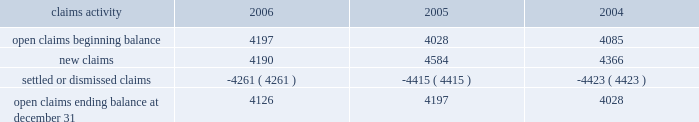Potentially responsible parties , and existing technology , laws , and regulations .
The ultimate liability for remediation is difficult to determine because of the number of potentially responsible parties involved , site- specific cost sharing arrangements with other potentially responsible parties , the degree of contamination by various wastes , the scarcity and quality of volumetric data related to many of the sites , and the speculative nature of remediation costs .
Current obligations are not expected to have a material adverse effect on our consolidated results of operations , financial condition , or liquidity .
Personal injury 2013 the cost of personal injuries to employees and others related to our activities is charged to expense based on estimates of the ultimate cost and number of incidents each year .
We use third-party actuaries to assist us with measuring the expense and liability , including unasserted claims .
The federal employers 2019 liability act ( fela ) governs compensation for work-related accidents .
Under fela , damages are assessed based on a finding of fault through litigation or out-of-court settlements .
We offer a comprehensive variety of services and rehabilitation programs for employees who are injured at work .
Annual expenses for personal injury-related events were $ 240 million in 2006 , $ 247 million in 2005 , and $ 288 million in 2004 .
As of december 31 , 2006 and 2005 , we had accrued liabilities of $ 631 million and $ 619 million for future personal injury costs , respectively , of which $ 233 million and $ 274 million was recorded in current liabilities as accrued casualty costs , respectively .
Our personal injury liability is discounted to present value using applicable u.s .
Treasury rates .
Approximately 87% ( 87 % ) of the recorded liability related to asserted claims , and approximately 13% ( 13 % ) related to unasserted claims .
Estimates can vary over time due to evolving trends in litigation .
Our personal injury claims activity was as follows : claims activity 2006 2005 2004 .
Depreciation 2013 the railroad industry is capital intensive .
Properties are carried at cost .
Provisions for depreciation are computed principally on the straight-line method based on estimated service lives of depreciable property .
The lives are calculated using a separate composite annual percentage rate for each depreciable property group , based on the results of internal depreciation studies .
We are required to submit a report on depreciation studies and proposed depreciation rates to the stb for review and approval every three years for equipment property and every six years for road property .
The cost ( net of salvage ) of depreciable railroad property retired or replaced in the ordinary course of business is charged to accumulated depreciation , and no gain or loss is recognized .
A gain or loss is recognized in other income for all other property upon disposition because the gain or loss is not part of rail operations .
The cost of internally developed software is capitalized and amortized over a five-year period .
Significant capital spending in recent years increased the total value of our depreciable assets .
Cash capital spending totaled $ 2.2 billion for the year ended december 31 , 2006 .
For the year ended december 31 , 2006 , depreciation expense was $ 1.2 billion .
We use various methods to estimate useful lives for each group of depreciable property .
Due to the capital intensive nature of the business and the large base of depreciable assets , variances to those estimates could have a material effect on our consolidated financial statements .
If the estimated useful lives of all depreciable assets were increased by one year , annual depreciation expense would decrease by approximately $ 43 million .
If the estimated useful lives of all assets to be depreciated were decreased by one year , annual depreciation expense would increase by approximately $ 45 million .
Income taxes 2013 as required under fasb statement no .
109 , accounting for income taxes , we account for income taxes by recording taxes payable or refundable for the current year and deferred tax assets and liabilities for the future tax consequences of events that have been recognized in our financial statements or tax returns .
These .
What was the percentage change in open claims ending balance at december 31 from 2004 to 2005? 
Computations: ((4197 - 4028) / 4028)
Answer: 0.04196. 